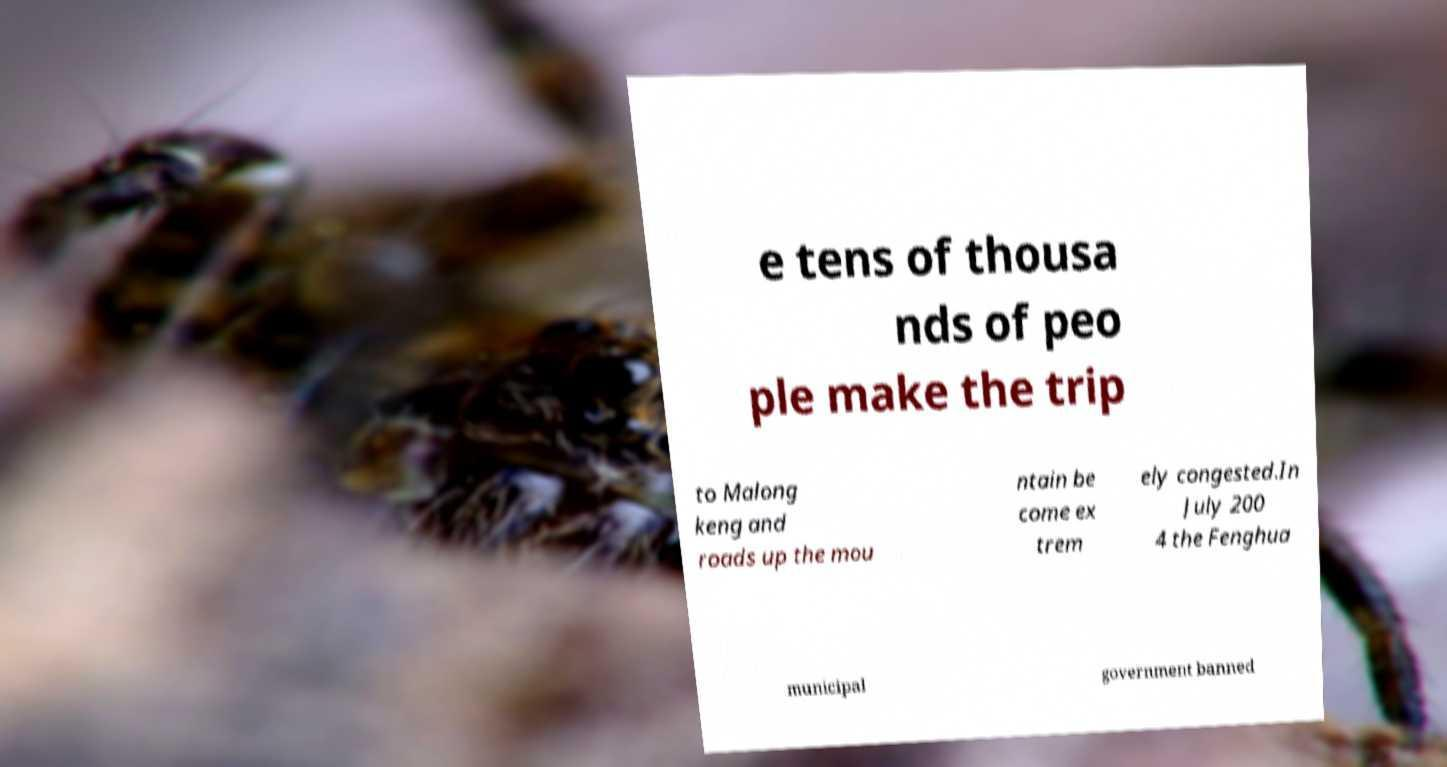For documentation purposes, I need the text within this image transcribed. Could you provide that? e tens of thousa nds of peo ple make the trip to Malong keng and roads up the mou ntain be come ex trem ely congested.In July 200 4 the Fenghua municipal government banned 